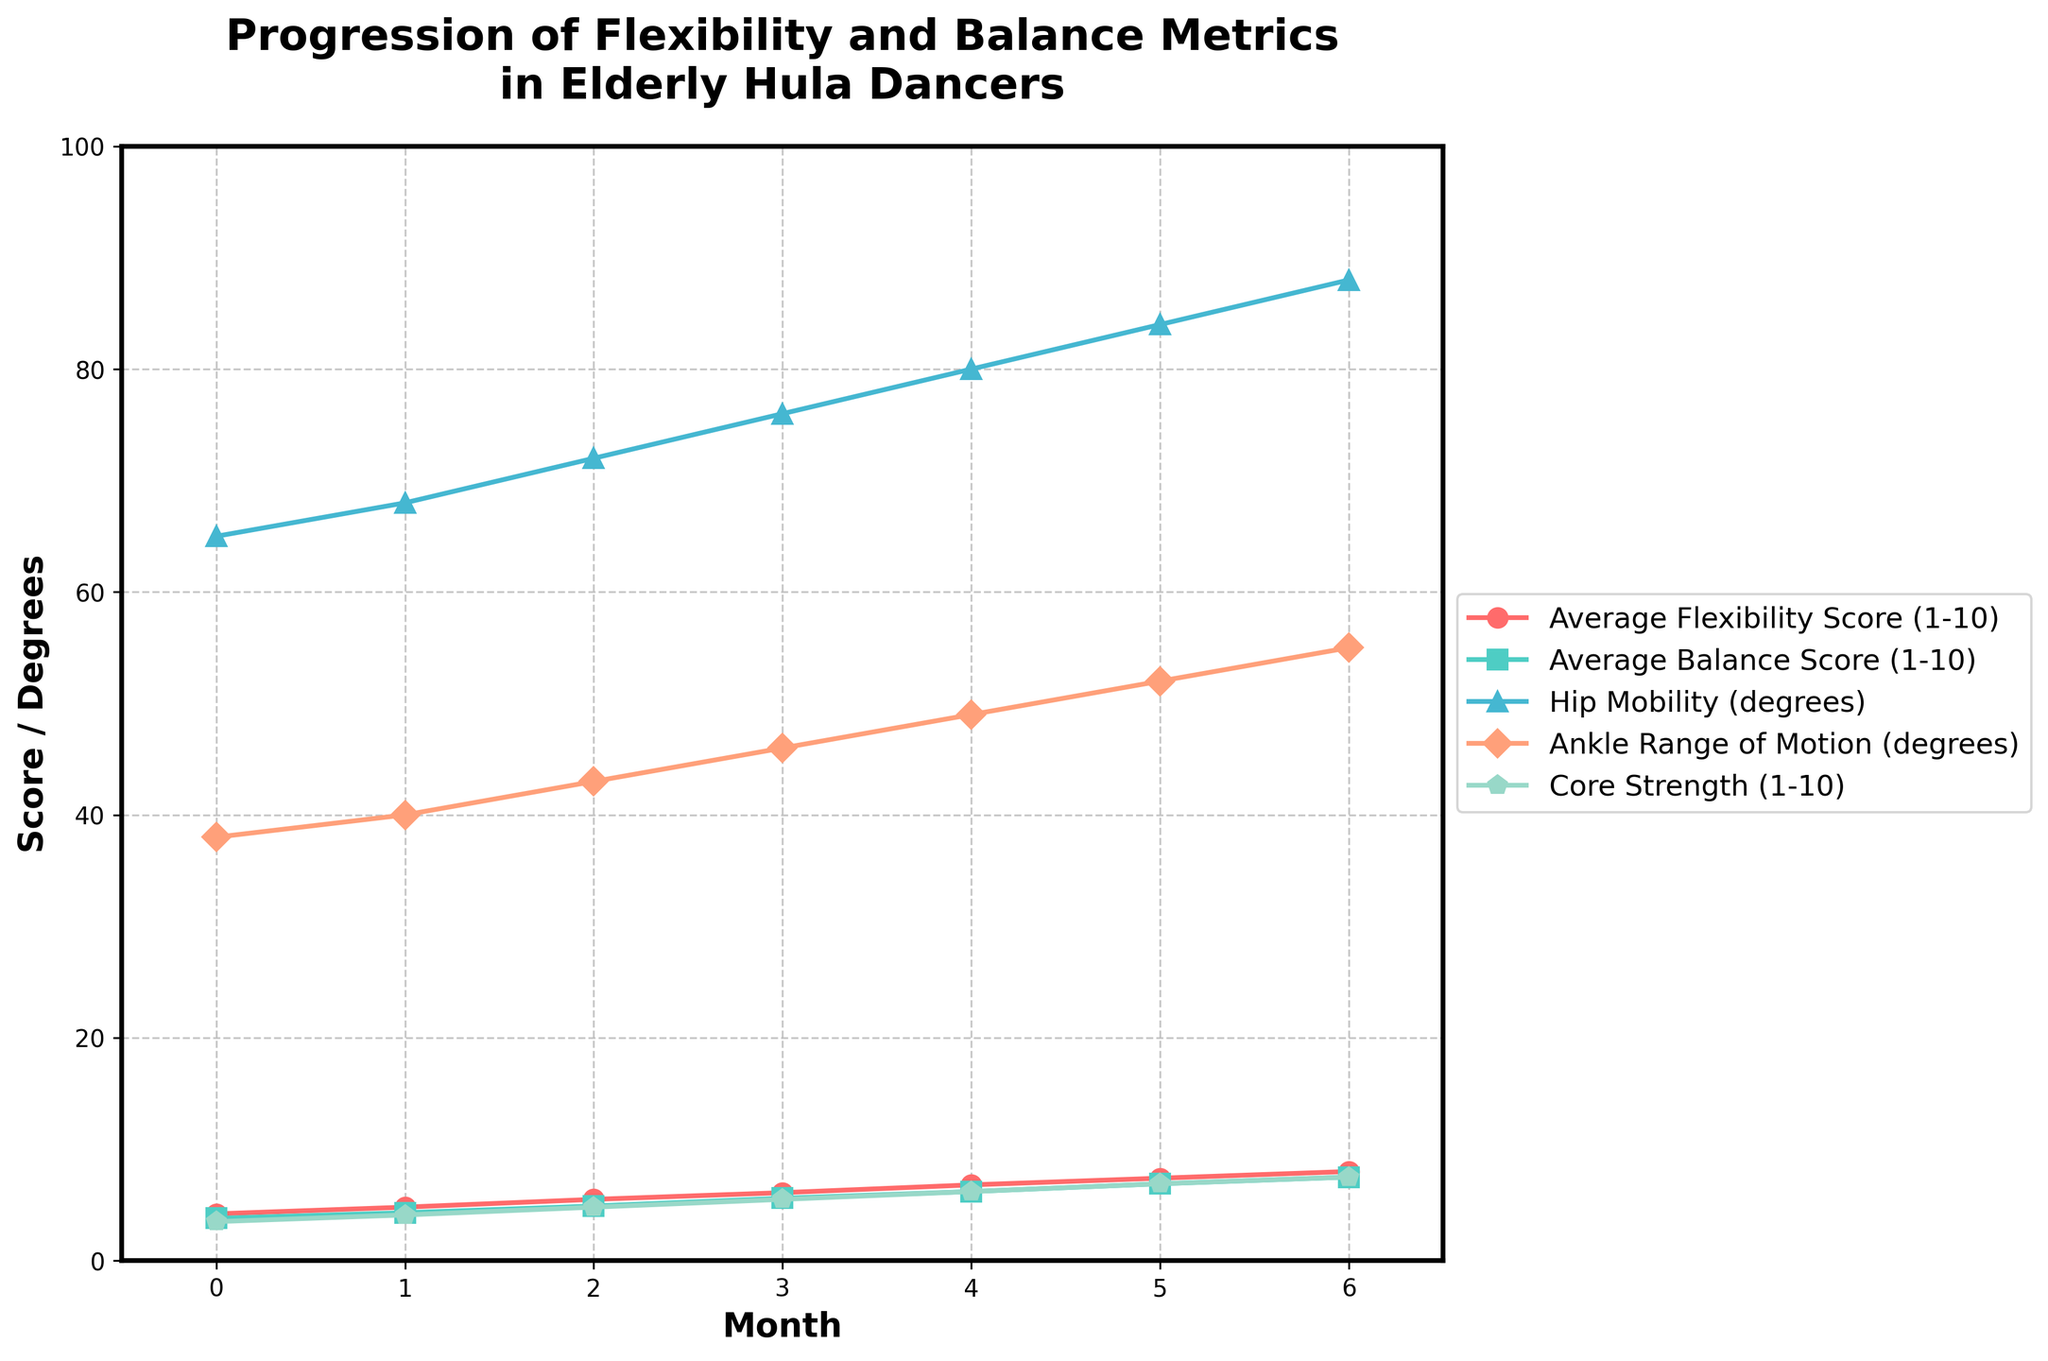Which metric shows the greatest improvement over the 6-month period? The 'Average Flexibility Score (1-10)' starts at 4.2 and reaches 8.0, an increase of 3.8 points. Comparing this with the other metrics, it has the highest improvement in value.
Answer: Average Flexibility Score What is the average 'Ankle Range of Motion (degrees)' over the 6-month period? Add the values for each month and divide by the number of months: (38 + 40 + 43 + 46 + 49 + 52 + 55) / 7 ≈ 46.14
Answer: 46.14 Which month shows the highest 'Core Strength (1-10)'? 'Core Strength' has a steady increase from 3.5 to 7.5 and reaches its peak at month 6.
Answer: Month 6 By how much does 'Average Balance Score (1-10)' improve from month 0 to month 6? Subtract the month 0 value from the month 6 value: 7.5 - 3.8 = 3.7
Answer: 3.7 Does 'Hip Mobility (degrees)' increase more or less than 'Core Strength (1-10)' from month 0 to month 6? Calculate the increase for both: 'Hip Mobility' increases from 65 to 88 (23 degrees), and 'Core Strength' increases from 3.5 to 7.5 (4 points). 23 (degrees) > 4 (points), so 'Hip Mobility' increases more.
Answer: More What observations can you make about the progression of 'Hip Mobility (degrees)' compared to 'Ankle Range of Motion (degrees)'? Both metrics continually increase over the 6-month period. 'Hip Mobility (degrees)' increases from 65 to 88 (23 degrees), and 'Ankle Range of Motion (degrees)' increases from 38 to 55 (17 degrees). 'Hip Mobility' has a slightly larger gain in degrees compared to 'Ankle Range of Motion'.
Answer: 'Hip Mobility' shows a larger increase In which month does 'Average Flexibility Score (1-10)' first surpass a score of 6? 'Average Flexibility Score (1-10)' is 6.1 in month 3, which is the first time it surpasses 6.
Answer: Month 3 